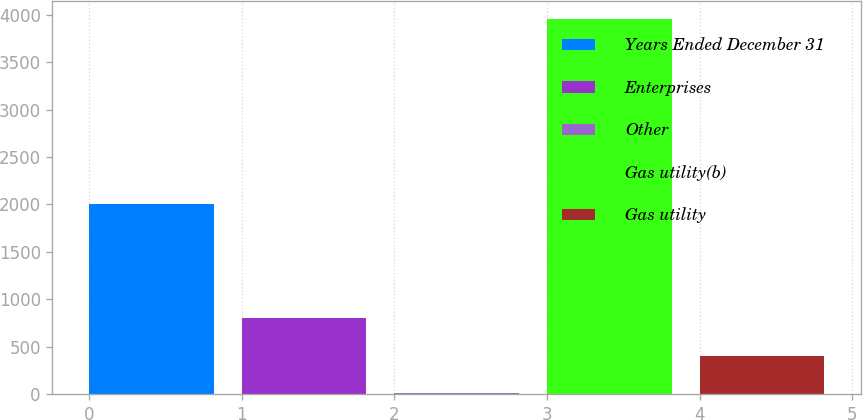<chart> <loc_0><loc_0><loc_500><loc_500><bar_chart><fcel>Years Ended December 31<fcel>Enterprises<fcel>Other<fcel>Gas utility(b)<fcel>Gas utility<nl><fcel>2006<fcel>798<fcel>10<fcel>3950<fcel>404<nl></chart> 